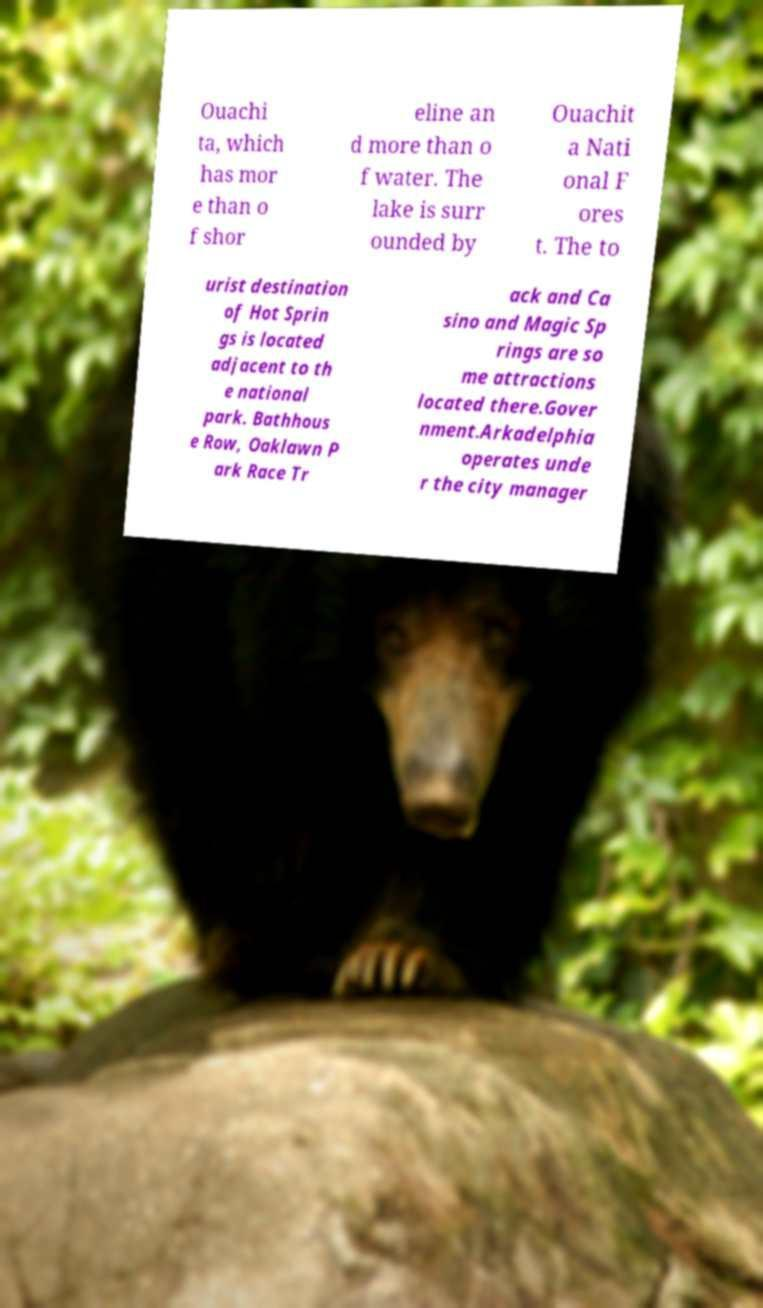For documentation purposes, I need the text within this image transcribed. Could you provide that? Ouachi ta, which has mor e than o f shor eline an d more than o f water. The lake is surr ounded by Ouachit a Nati onal F ores t. The to urist destination of Hot Sprin gs is located adjacent to th e national park. Bathhous e Row, Oaklawn P ark Race Tr ack and Ca sino and Magic Sp rings are so me attractions located there.Gover nment.Arkadelphia operates unde r the city manager 